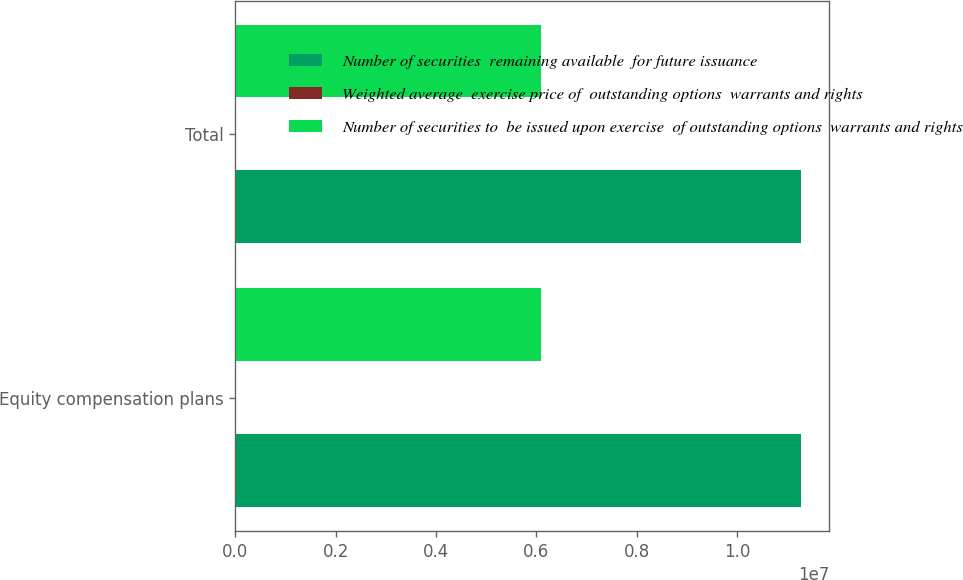Convert chart. <chart><loc_0><loc_0><loc_500><loc_500><stacked_bar_chart><ecel><fcel>Equity compensation plans<fcel>Total<nl><fcel>Number of securities  remaining available  for future issuance<fcel>1.12799e+07<fcel>1.12799e+07<nl><fcel>Weighted average  exercise price of  outstanding options  warrants and rights<fcel>19.72<fcel>19.72<nl><fcel>Number of securities to  be issued upon exercise  of outstanding options  warrants and rights<fcel>6.10338e+06<fcel>6.10338e+06<nl></chart> 